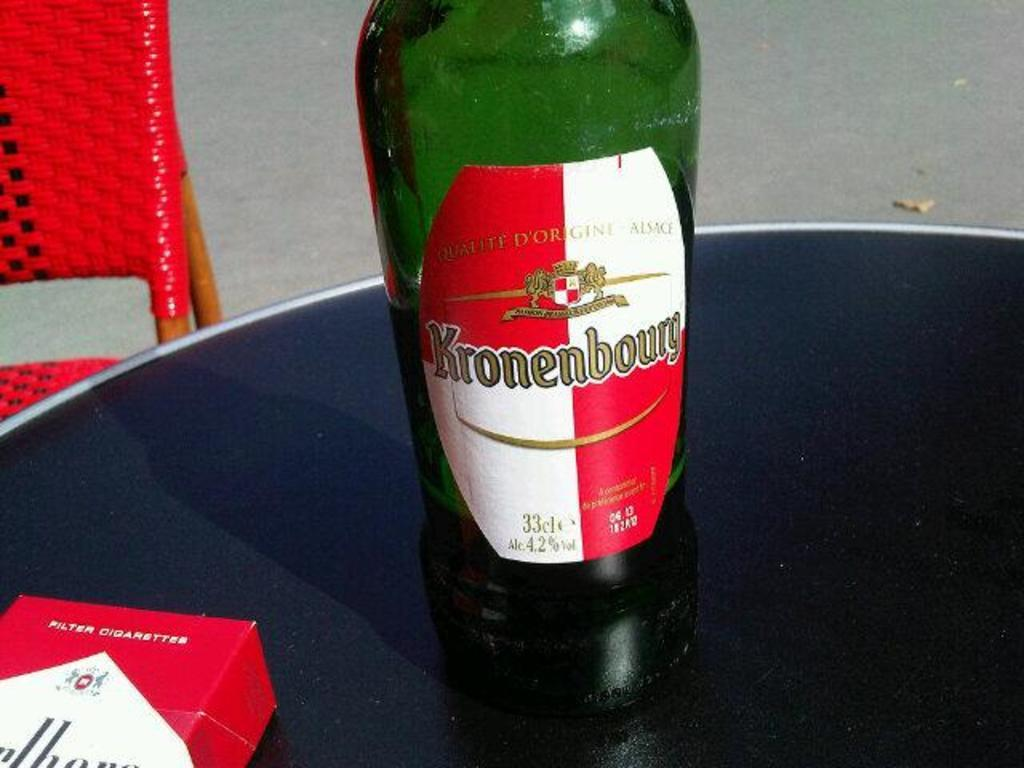What is on the table in the image? There is an alcohol bottle and a box on the table in the image. What color is the chair behind the table? The chair behind the table is red. What type of doctor is sitting in the red chair in the image? There is no doctor present in the image; it only features an alcohol bottle, a box, and a red chair. How does the earth relate to the objects in the image? The earth is not depicted in the image, and therefore it cannot be related to the objects present. 